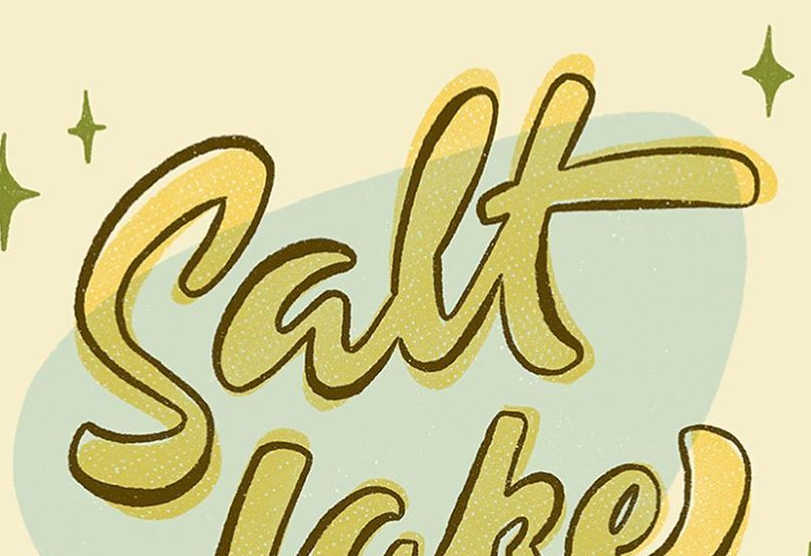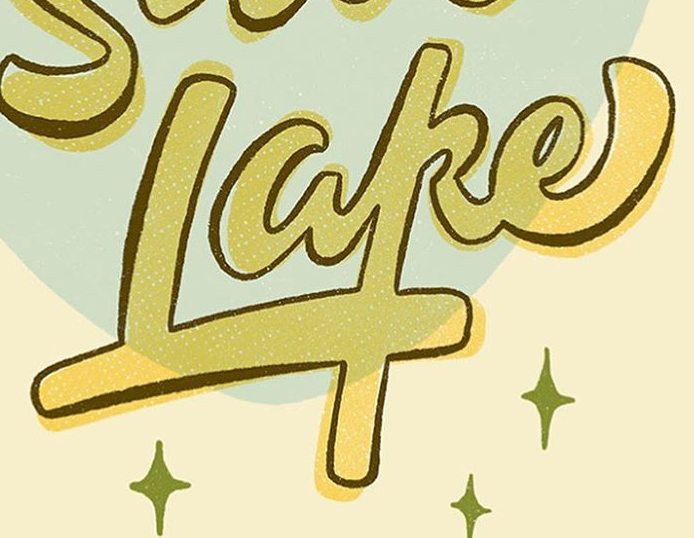Identify the words shown in these images in order, separated by a semicolon. Salt; Lake 